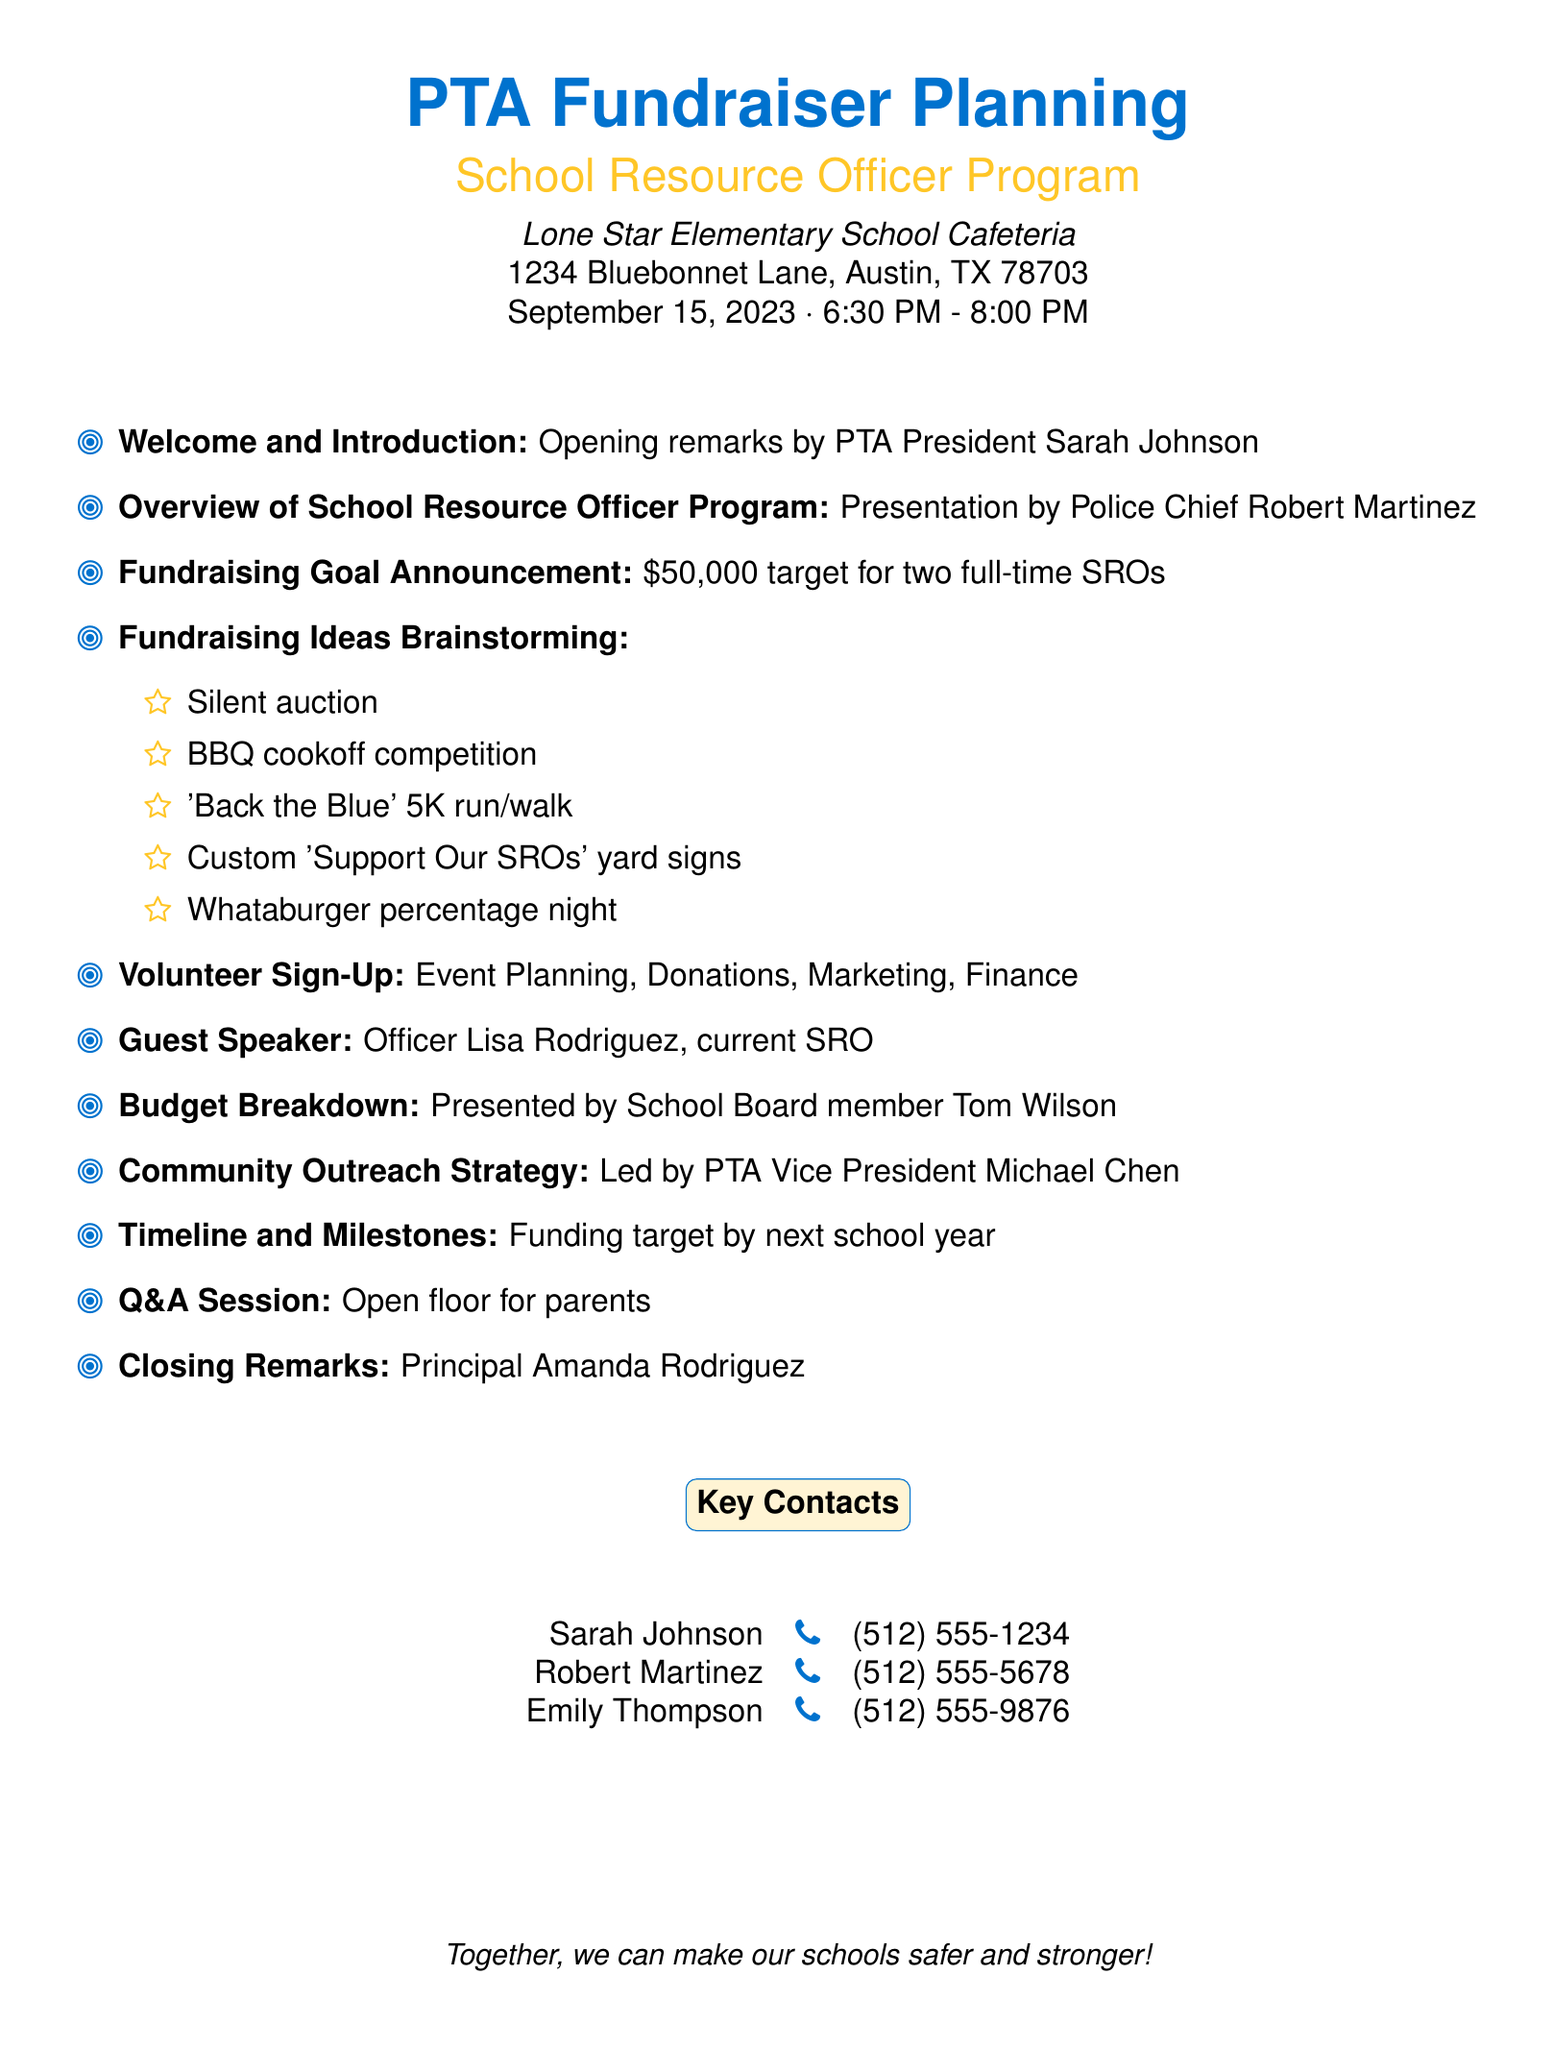What is the fundraising goal amount? The fundraising goal amount is specifically stated in the document as $50,000 needed to fund two full-time SROs.
Answer: $50,000 Who is the guest speaker at the event? The document mentions Officer Lisa Rodriguez as the guest speaker who is the current SRO.
Answer: Officer Lisa Rodriguez What is the venue for the fundraiser? The venue information includes the name of the location, which is specified in the document as Lone Star Elementary School Cafeteria.
Answer: Lone Star Elementary School Cafeteria What date and time is the event scheduled for? The document provides the date and time for the event, which is September 15, 2023, from 6:30 PM to 8:00 PM.
Answer: September 15, 2023, 6:30 PM - 8:00 PM What role does Emily Thompson have? The document lists Emily Thompson's role as PTA Treasurer in the key contacts section.
Answer: PTA Treasurer How many full-time SROs are being funded by the fundraiser? The agenda highlights the funding for two full-time SROs as part of the fundraising goal.
Answer: Two Who will present the budget breakdown? The budget breakdown is to be presented by School Board member Tom Wilson as stated in the document.
Answer: Tom Wilson What community engagement strategy is mentioned? The document addresses involving local churches, businesses, and community organizations in the fundraising efforts.
Answer: Community organizations What type of event is the BBQ competition? The BBQ cookoff competition is one of the fundraising ideas presented in the brainstorming session noted in the agenda.
Answer: Fundraising idea 